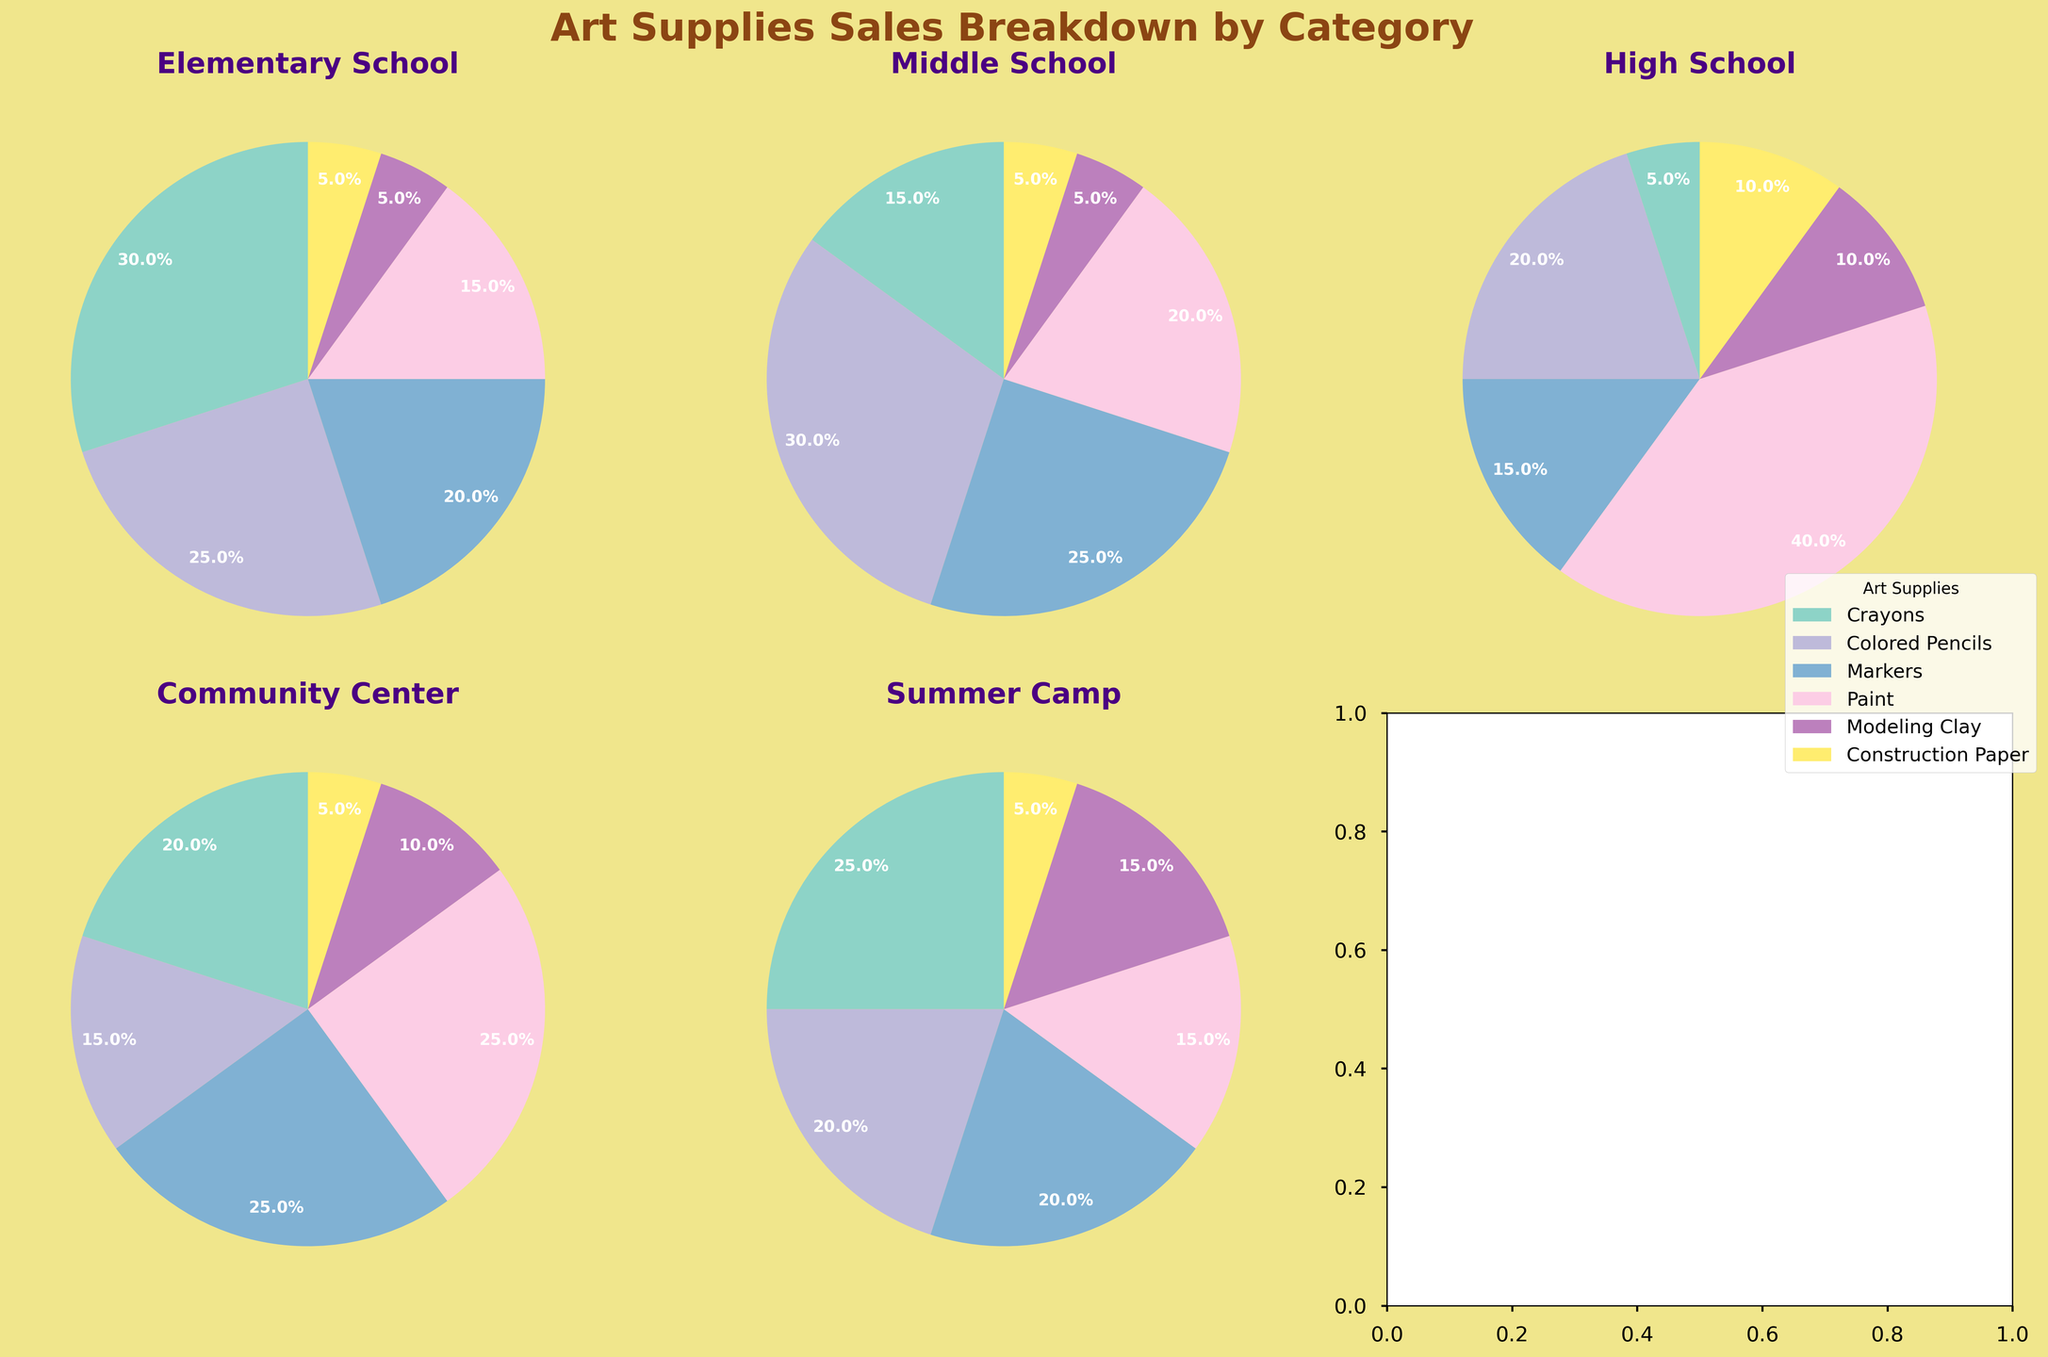Which category has the highest percentage of Paint sales? Look at each pie chart and identify the category with the largest Paint segment (usually colored differently from other supplies). The High School pie chart shows a substantial Paint segment, indicating the highest percentage.
Answer: High School What is the total percentage of Crayons and Colored Pencils used in Elementary School? Sum the percentages of Crayons and Colored Pencils in the Elementary School pie chart. Crayons are 30%, and Colored Pencils are 25%, so their total is 30% + 25%.
Answer: 55% Which category has an equal percentage of Construction Paper and Modeling Clay sales? Find pie charts where the sections for Construction Paper and Modeling Clay are the same size. Both are 5% in Elementary School and Middle School categories.
Answer: Elementary School, Middle School Which category has the lowest percentage of Markers sales? Compare the Markers segment across all pie charts. The High School chart shows the smallest portion for Markers, indicating the lowest percentage.
Answer: High School What is the average percentage of Paint sales across all categories? Sum the percentages of Paint sales for all categories (15% + 20% + 40% + 25% + 15%). Then divide by the number of categories (5). The calculation is (15 + 20 + 40 + 25 + 15) / 5.
Answer: 23% Which categories have more than 20% of Marker sales? Identify the categories where the Markers segment exceeds 20%. In Elementary School, Middle School, and Community Center pie charts, the percentage is above 20%.
Answer: Middle School, Community Center How much greater is Paint sales percentage in High School compared to Elementary School? Subtract the Paint percentage in Elementary School from that of High School. Paint is 40% in High School and 15% in Elementary School, so the difference is 40% - 15%.
Answer: 25% In which category is the percentage of Colored Pencils sales highest? Look at the pie charts and find the largest segment for Colored Pencils. Middle School has the largest percentage for Colored Pencils at 30%.
Answer: Middle School Compare the percentage use of Modeling Clay at Summer Camp and High School. Which is greater, and by how much? Check the Modeling Clay segments in both categories. Summer Camp has 15% and High School has 10%. The difference is 15% - 10%.
Answer: Summer Camp, 5% What is the combined percentage of Modeling Clay and Construction Paper sales at the Community Center? Add the percentages of Modeling Clay and Construction Paper in the Community Center pie chart. Modeling Clay is 10% and Construction Paper is 5%, so their total is 10% + 5%.
Answer: 15% 